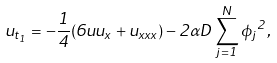<formula> <loc_0><loc_0><loc_500><loc_500>u _ { t _ { 1 } } = - \frac { 1 } { 4 } ( 6 u u _ { x } + u _ { x x x } ) - 2 \alpha D \sum _ { j = 1 } ^ { N } { \phi _ { j } } ^ { 2 } ,</formula> 